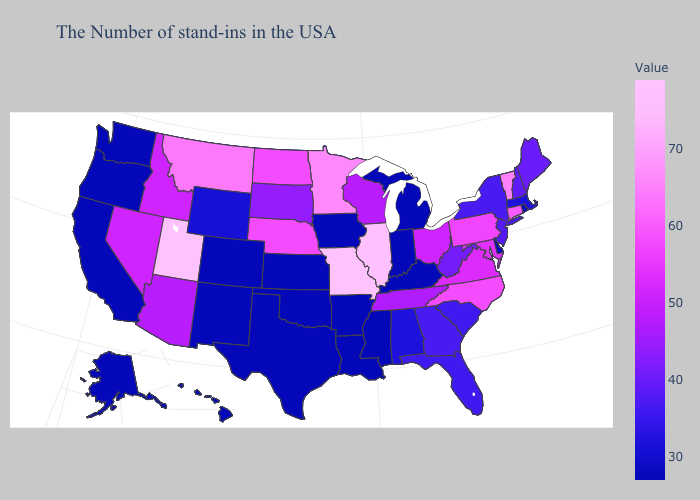Among the states that border Mississippi , which have the lowest value?
Keep it brief. Louisiana, Arkansas. Which states have the highest value in the USA?
Concise answer only. Missouri, Utah. Does Oregon have the lowest value in the USA?
Answer briefly. Yes. Among the states that border Texas , which have the highest value?
Give a very brief answer. Louisiana, Arkansas, Oklahoma, New Mexico. Which states have the lowest value in the South?
Be succinct. Delaware, Kentucky, Mississippi, Louisiana, Arkansas, Oklahoma, Texas. Among the states that border Idaho , does Montana have the highest value?
Quick response, please. No. 